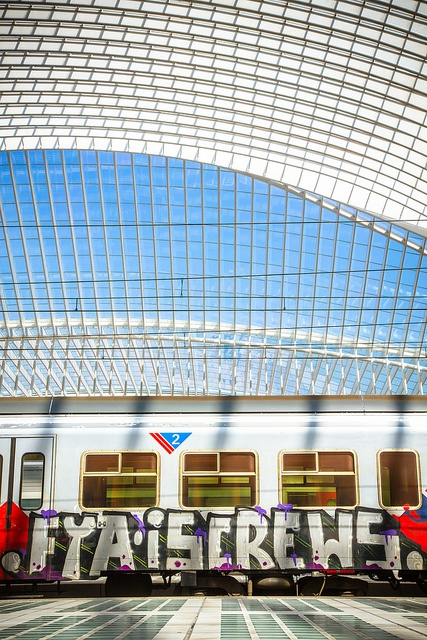Describe the objects in this image and their specific colors. I can see a train in blue, white, black, darkgray, and olive tones in this image. 